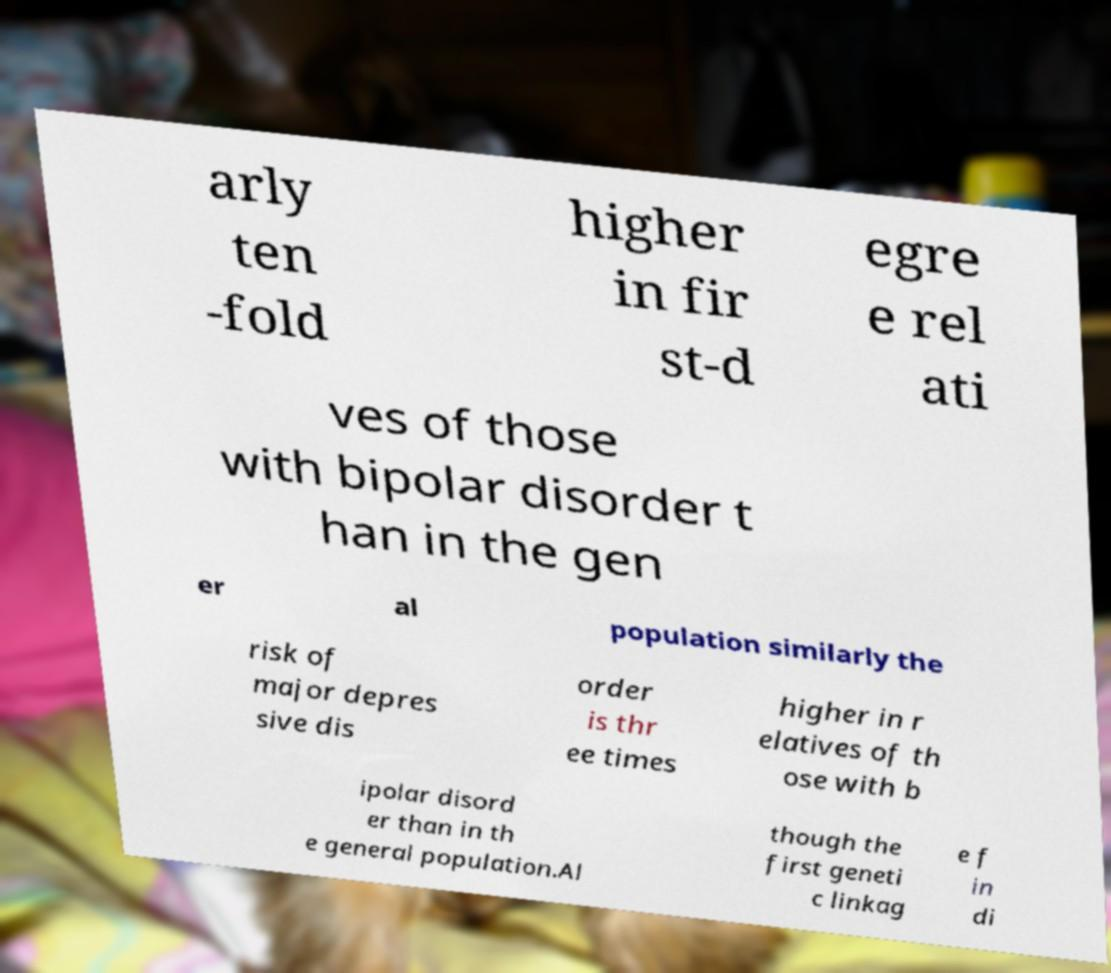Can you read and provide the text displayed in the image?This photo seems to have some interesting text. Can you extract and type it out for me? arly ten -fold higher in fir st-d egre e rel ati ves of those with bipolar disorder t han in the gen er al population similarly the risk of major depres sive dis order is thr ee times higher in r elatives of th ose with b ipolar disord er than in th e general population.Al though the first geneti c linkag e f in di 